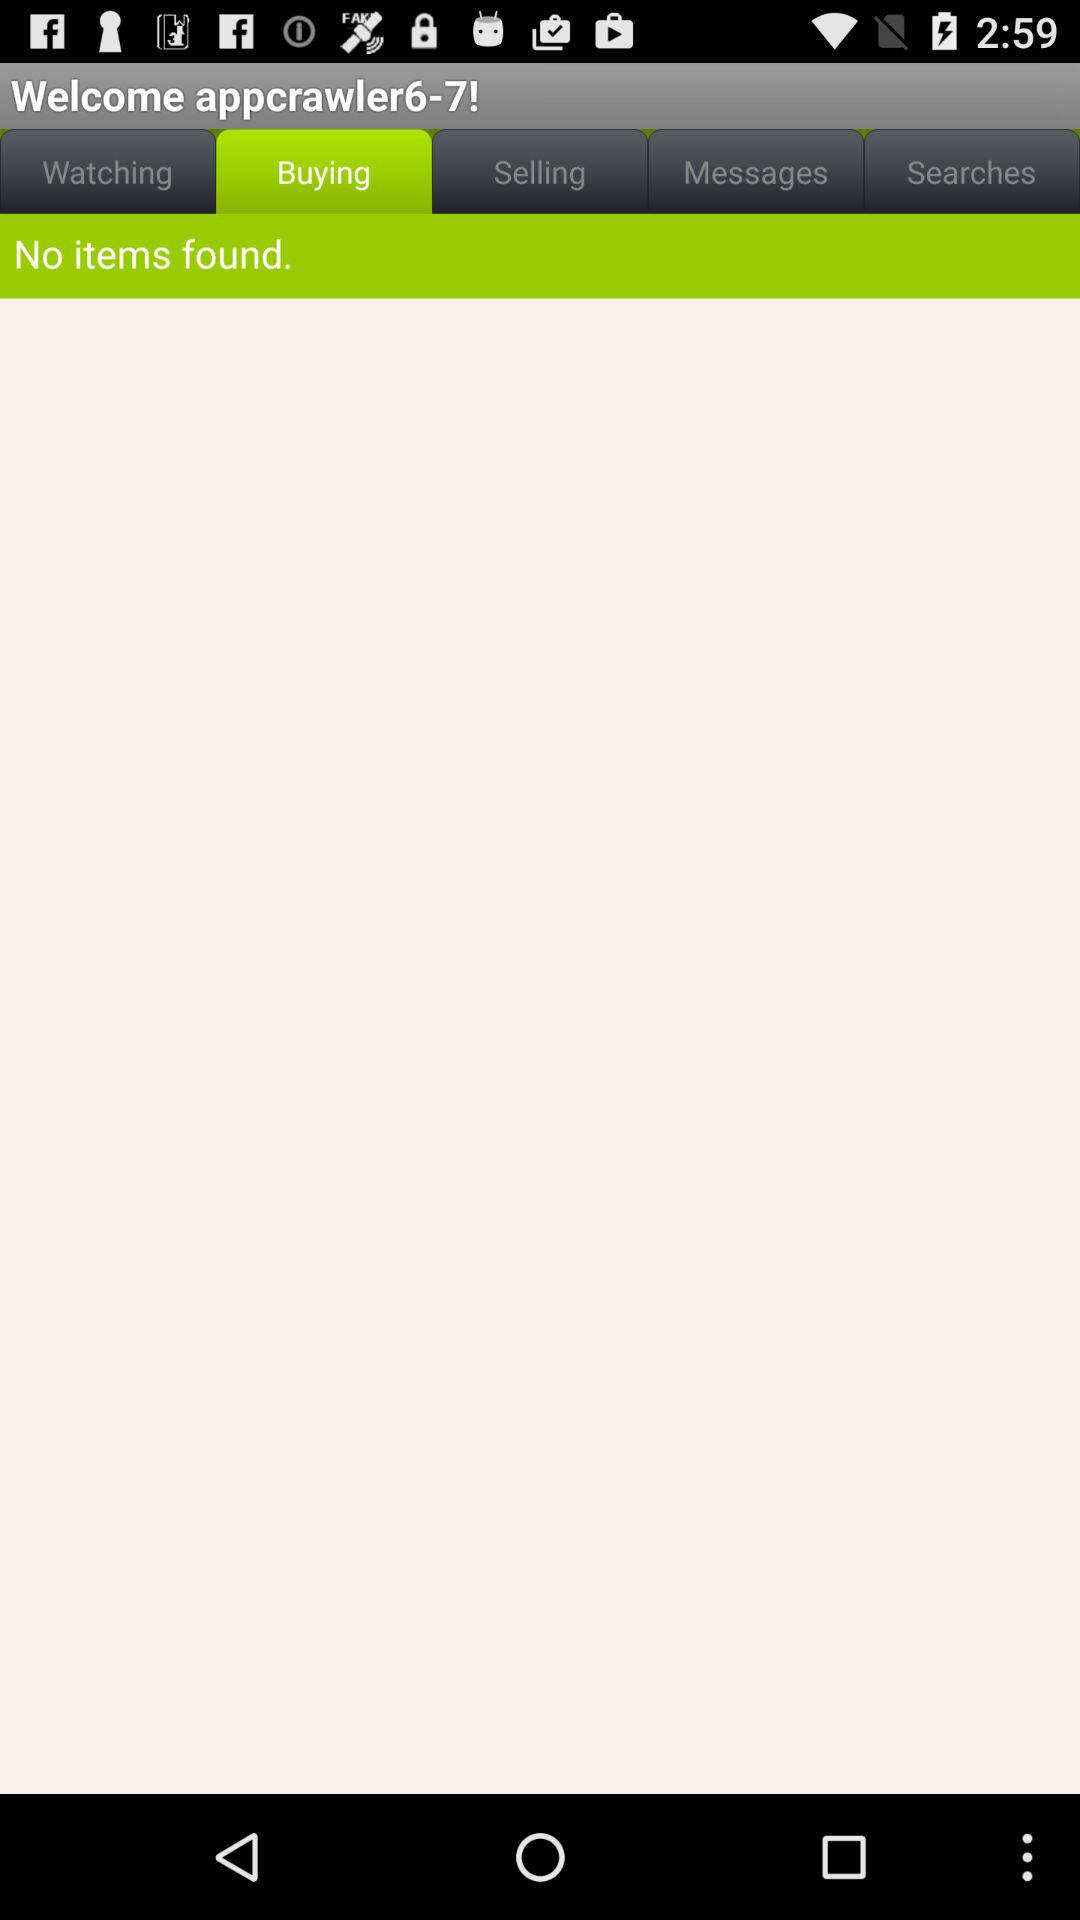Which tab is selected? The selected tab is "Buying". 